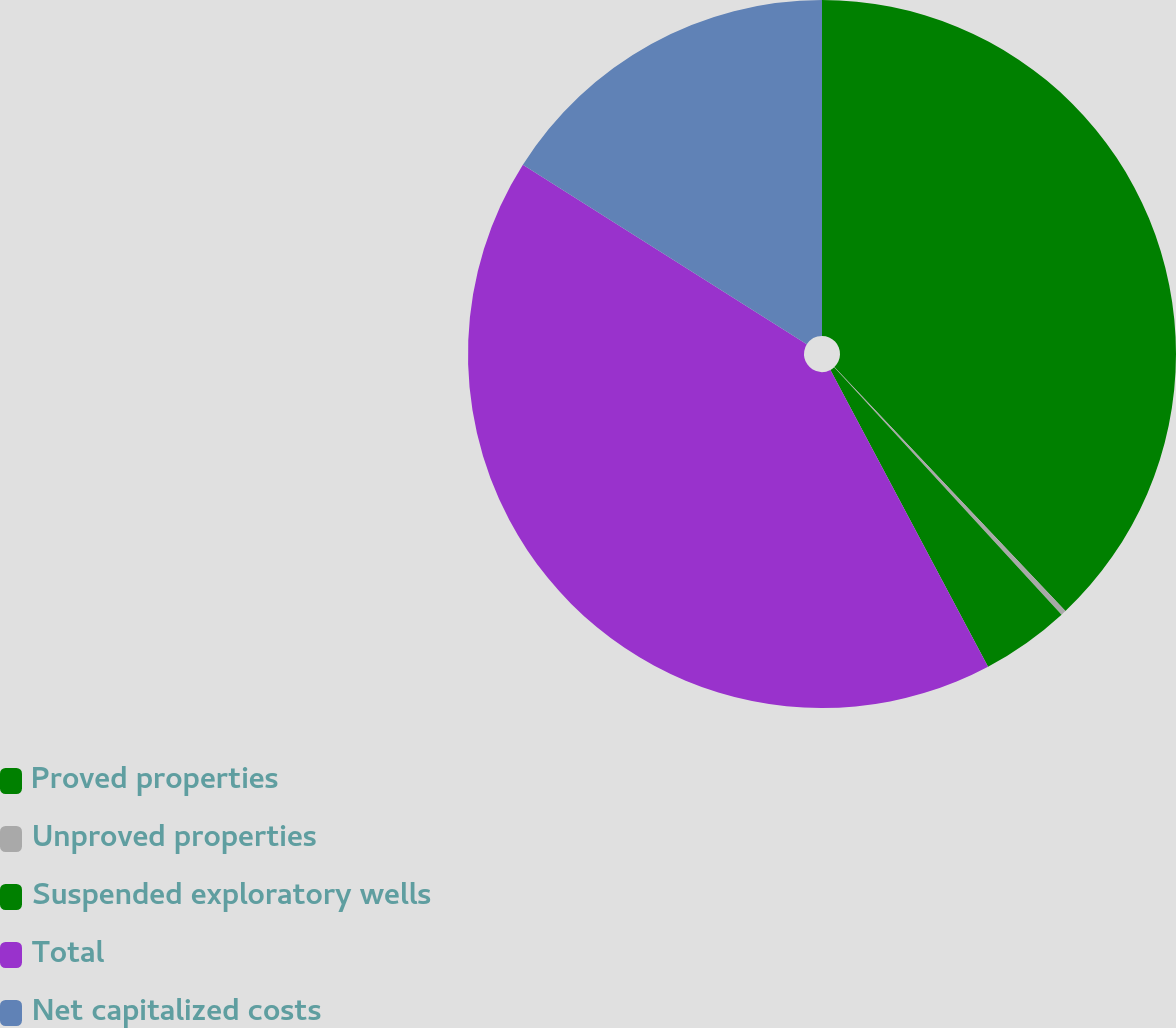Convert chart to OTSL. <chart><loc_0><loc_0><loc_500><loc_500><pie_chart><fcel>Proved properties<fcel>Unproved properties<fcel>Suspended exploratory wells<fcel>Total<fcel>Net capitalized costs<nl><fcel>37.93%<fcel>0.24%<fcel>4.06%<fcel>41.75%<fcel>16.02%<nl></chart> 